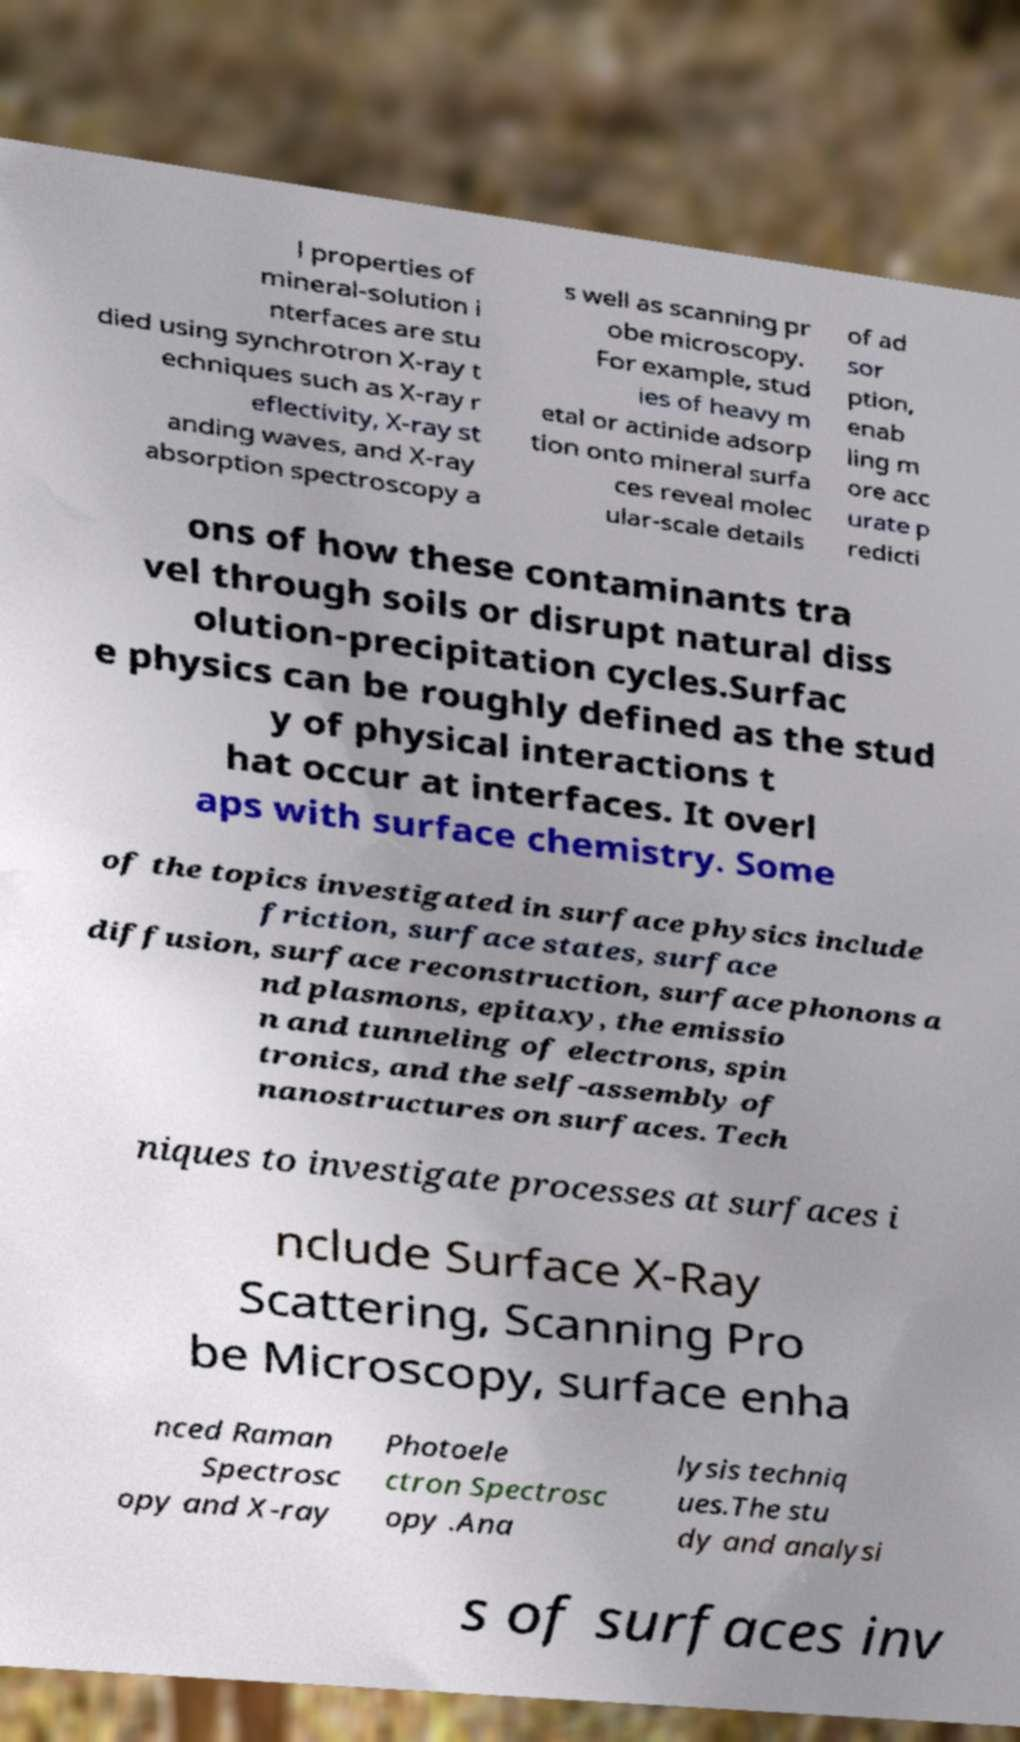I need the written content from this picture converted into text. Can you do that? l properties of mineral-solution i nterfaces are stu died using synchrotron X-ray t echniques such as X-ray r eflectivity, X-ray st anding waves, and X-ray absorption spectroscopy a s well as scanning pr obe microscopy. For example, stud ies of heavy m etal or actinide adsorp tion onto mineral surfa ces reveal molec ular-scale details of ad sor ption, enab ling m ore acc urate p redicti ons of how these contaminants tra vel through soils or disrupt natural diss olution-precipitation cycles.Surfac e physics can be roughly defined as the stud y of physical interactions t hat occur at interfaces. It overl aps with surface chemistry. Some of the topics investigated in surface physics include friction, surface states, surface diffusion, surface reconstruction, surface phonons a nd plasmons, epitaxy, the emissio n and tunneling of electrons, spin tronics, and the self-assembly of nanostructures on surfaces. Tech niques to investigate processes at surfaces i nclude Surface X-Ray Scattering, Scanning Pro be Microscopy, surface enha nced Raman Spectrosc opy and X-ray Photoele ctron Spectrosc opy .Ana lysis techniq ues.The stu dy and analysi s of surfaces inv 